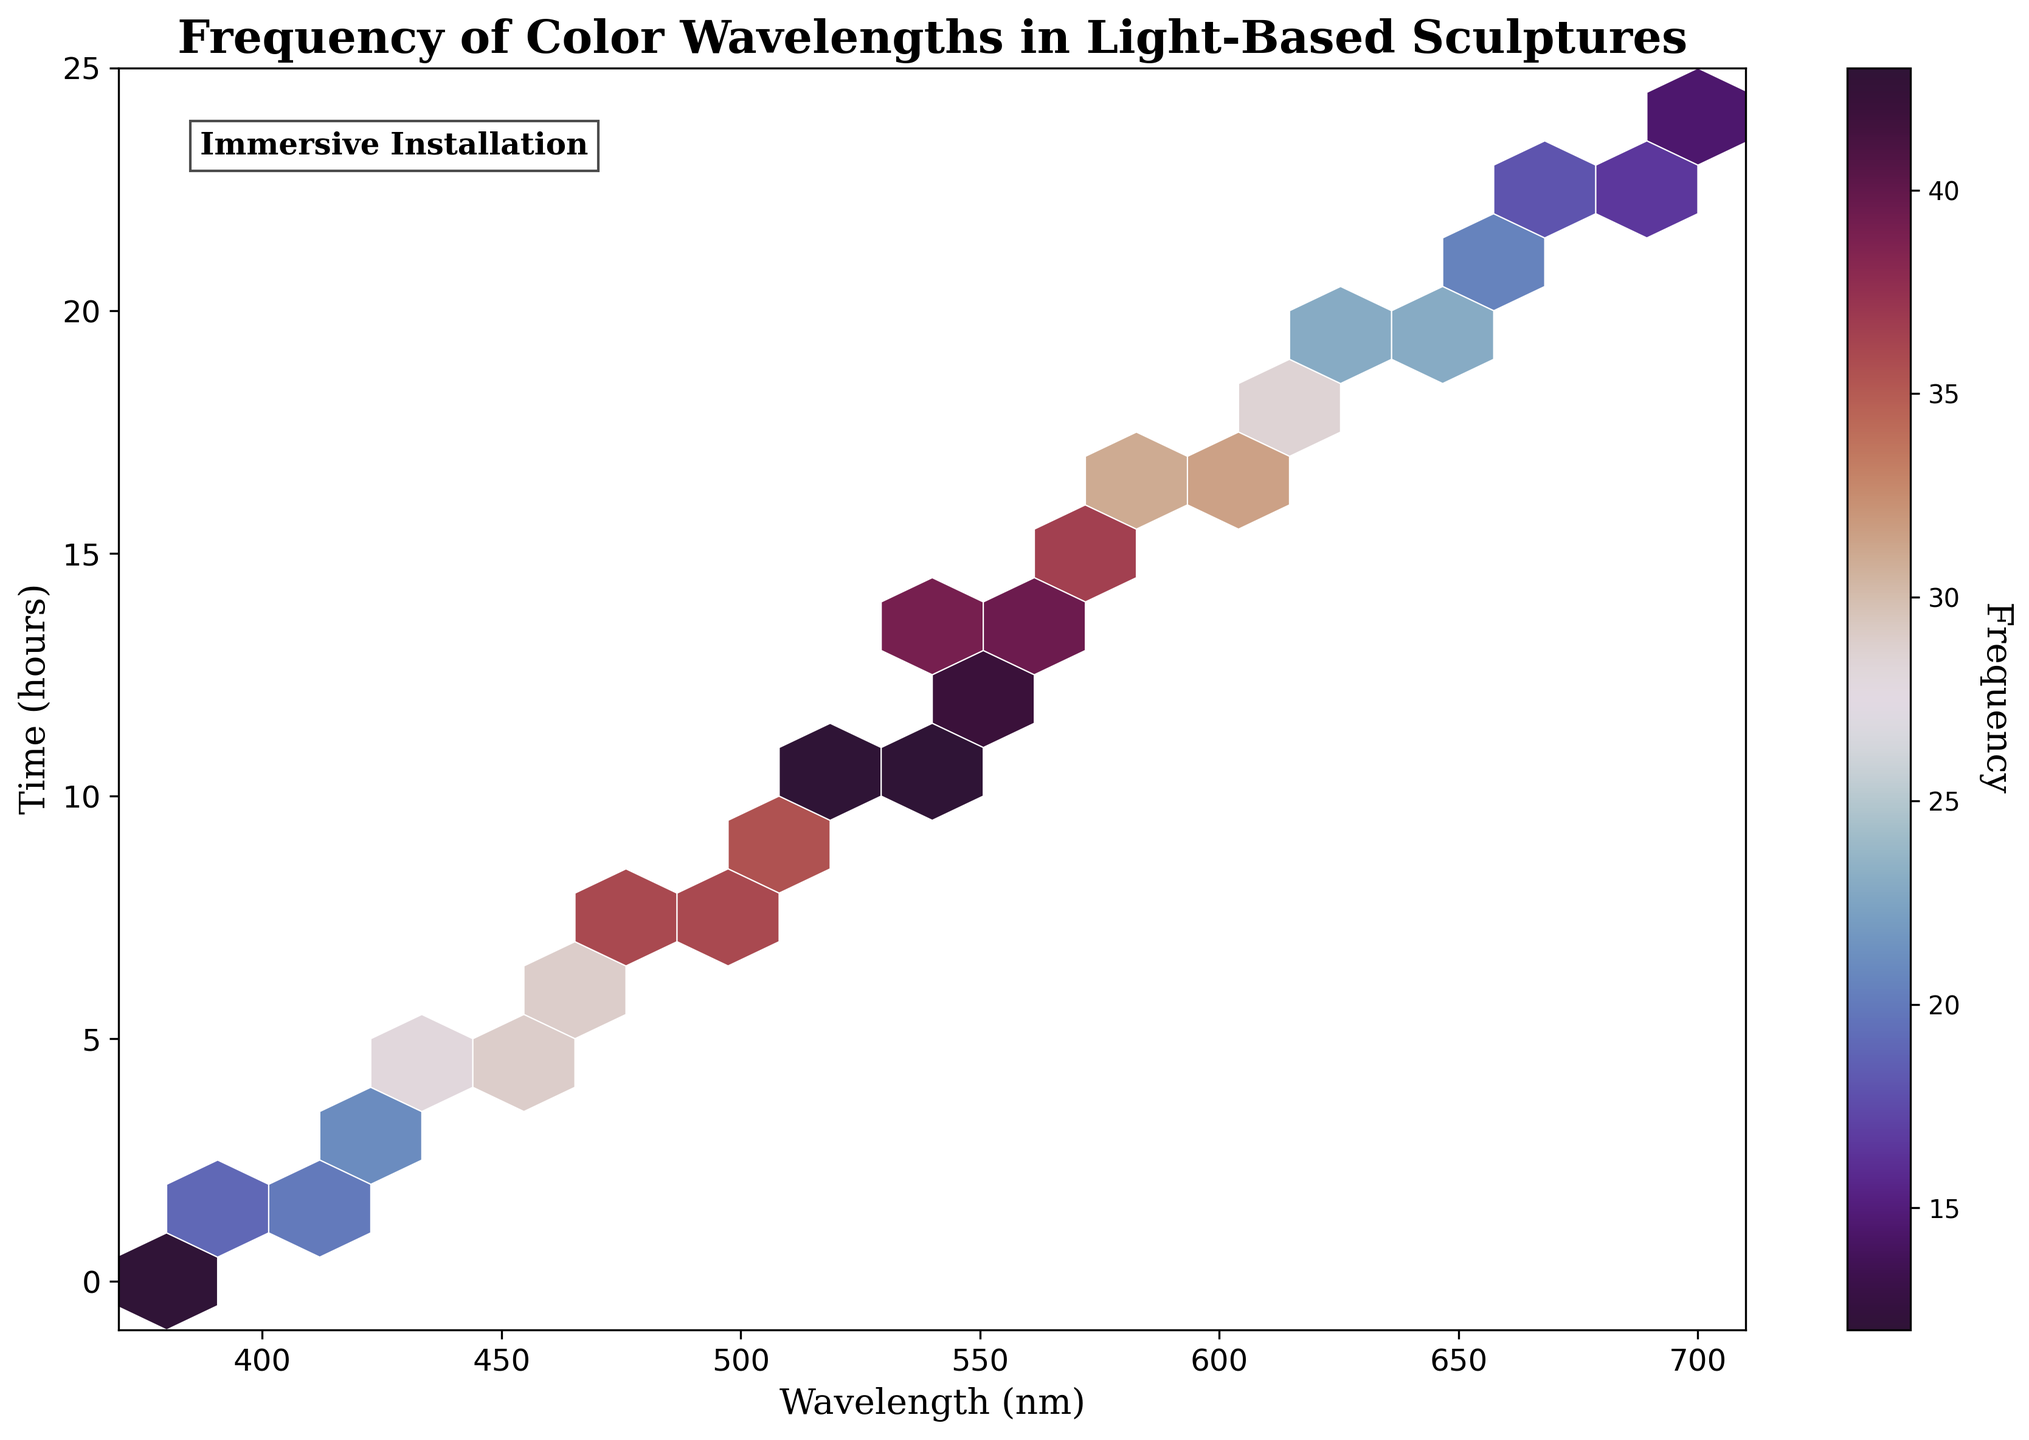What is the title of the plot? The title of the plot is found at the top of the figure. It indicates the context or the subject matter of the plot.
Answer: Frequency of Color Wavelengths in Light-Based Sculptures What do the x-axis and y-axis represent? Axes labels describe what the respective axis measures. The x-axis label is 'Wavelength (nm)' and the y-axis label is 'Time (hours)'.
Answer: Wavelength (nm) on the x-axis and Time (hours) on the y-axis What is the color legend's label? The color legend, or color bar, provides information on what the color intensity represents. The label is located beside the color bar.
Answer: Frequency Which color corresponds to the highest frequency in the color map? The color map uses a gradient to signify frequency, with the highest frequency represented by the most intense color.
Answer: Dark purple Between what hours is the frequency of wavelengths around 500 nm the highest? By checking the hexbin plot where x values around 500 nm correspond to the y-values representing time, look for the highest color intensity.
Answer: 9 to 12 hours What is the range of wavelengths displayed on the x-axis? The range of the x-axis can be determined by reading the minimum and maximum values on the axis ticks.
Answer: 370 nm to 710 nm How does the frequency distribution of wavelengths at 700 nm compare between 0-hour and 24-hour? Observing the color intensity of the hexbin at 700 nm for both 0-hour and 24-hour will show the difference in frequency.
Answer: Higher at 24-hour What is the average frequency for wavelengths at hour 15? Identify the color intensities at 15 hours for all relevant wavelengths, sum them, and divide by the number of these points.
Answer: (35 + 38) / 2 = 36.5 Which time interval (12 hours to 14 hours) shows the highest frequency for any wavelength? Compare the color intensities within the bins for both 12-hour and 14-hour across all wavelengths.
Answer: 12 hours with frequency 40 